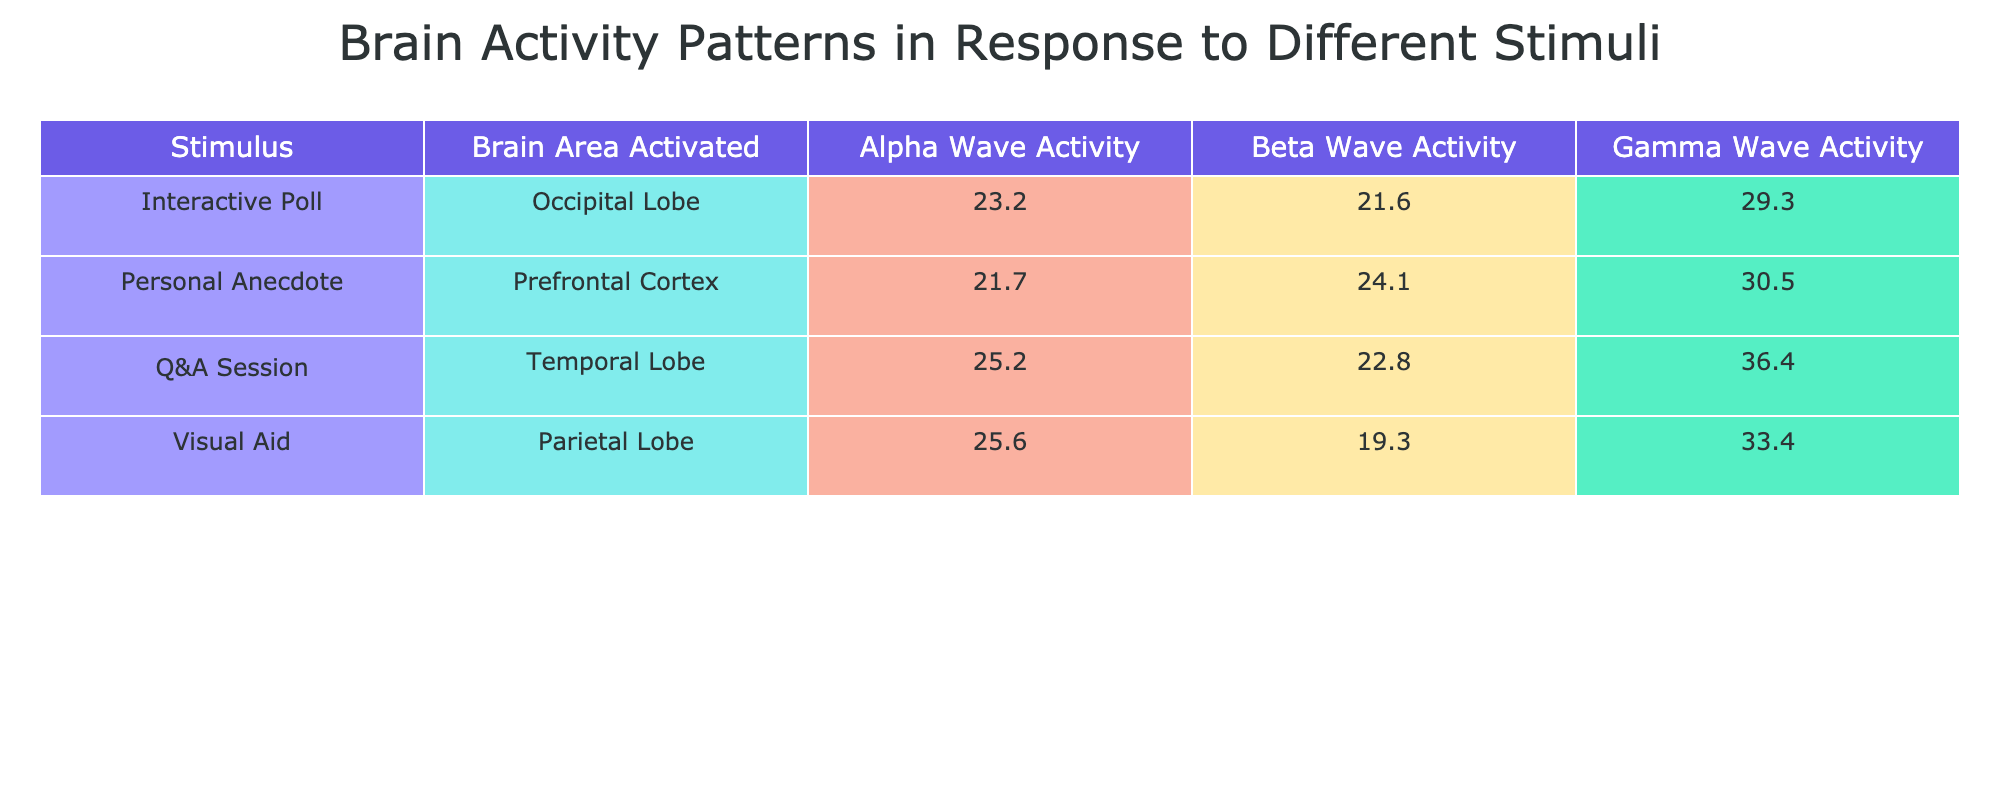What is the brain area activated during the Q&A session? According to the table, during the Q&A session, the brain area activated is the Prefrontal Cortex.
Answer: Prefrontal Cortex Which stimulus shows the highest average Gamma Wave Activity? We look at the Gamma Wave Activity values for each stimulus: Visual Aid (32.7, 34.0, 33.5), Q&A Session (35.2, 36.8, 37.1), Personal Anecdote (30.1, 31.5, 29.8), and Interactive Poll (28.6, 29.0, 30.2). The highest average Gamma Wave Activity is found in the Q&A Session (average of 36.3).
Answer: Q&A Session What is the average Alpha Wave Activity for the Personal Anecdote? The Alpha Wave Activity for Personal Anecdote includes the values (20.8, 21.9, 22.5). To find the average, we sum these (20.8 + 21.9 + 22.5 = 65.2) and divide by the number of participants (3), giving us 65.2 / 3 = approximately 21.73.
Answer: 21.7 Is the average Beta Wave Activity for the Visual Aid greater than 20? The Beta Wave Activity values for Visual Aid are (18.1, 19.2, 20.6). The average is (18.1 + 19.2 + 20.6) / 3 = 19.3, which is not greater than 20.
Answer: No Which stimulus has the lowest average Alpha Wave Activity? We examine the Alpha Wave Activity: for Visual Aid (25.4, 24.3, 27.0), Q&A Session (23.5, 26.2, 25.8), Personal Anecdote (20.8, 21.9, 22.5), and Interactive Poll (22.0, 23.1, 24.5). The averages are about 25.3, 25.2, 21.7, and 23.2 respectively. Therefore, the stimulus with the lowest average Alpha Wave Activity is Personal Anecdote.
Answer: Personal Anecdote How does the average Beta Wave Activity compare between Interactive Poll and Personal Anecdote? The Beta Wave Activity for Interactive Poll is (20.5, 23.3, 21.0), averaging to about 21.6. For Personal Anecdote, it is (25.4, 24.0, 22.9), averaging to about 24.1. The average for Personal Anecdote (24.1) is greater than that for Interactive Poll (21.6).
Answer: Personal Anecdote has higher Beta Wave Activity 